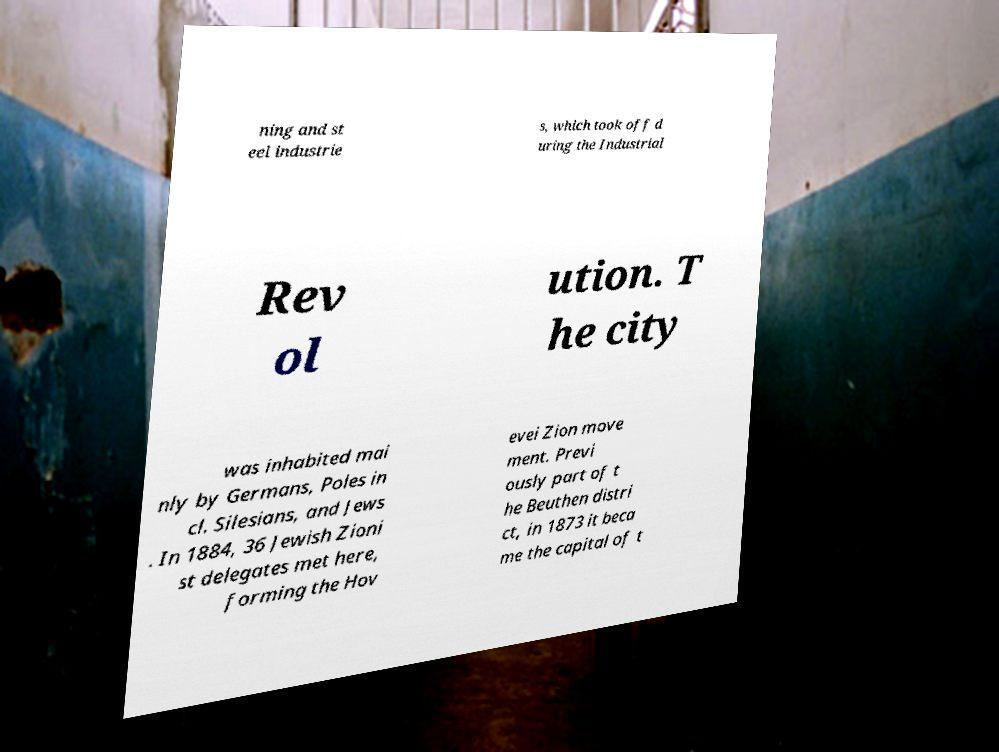Could you assist in decoding the text presented in this image and type it out clearly? ning and st eel industrie s, which took off d uring the Industrial Rev ol ution. T he city was inhabited mai nly by Germans, Poles in cl. Silesians, and Jews . In 1884, 36 Jewish Zioni st delegates met here, forming the Hov evei Zion move ment. Previ ously part of t he Beuthen distri ct, in 1873 it beca me the capital of t 